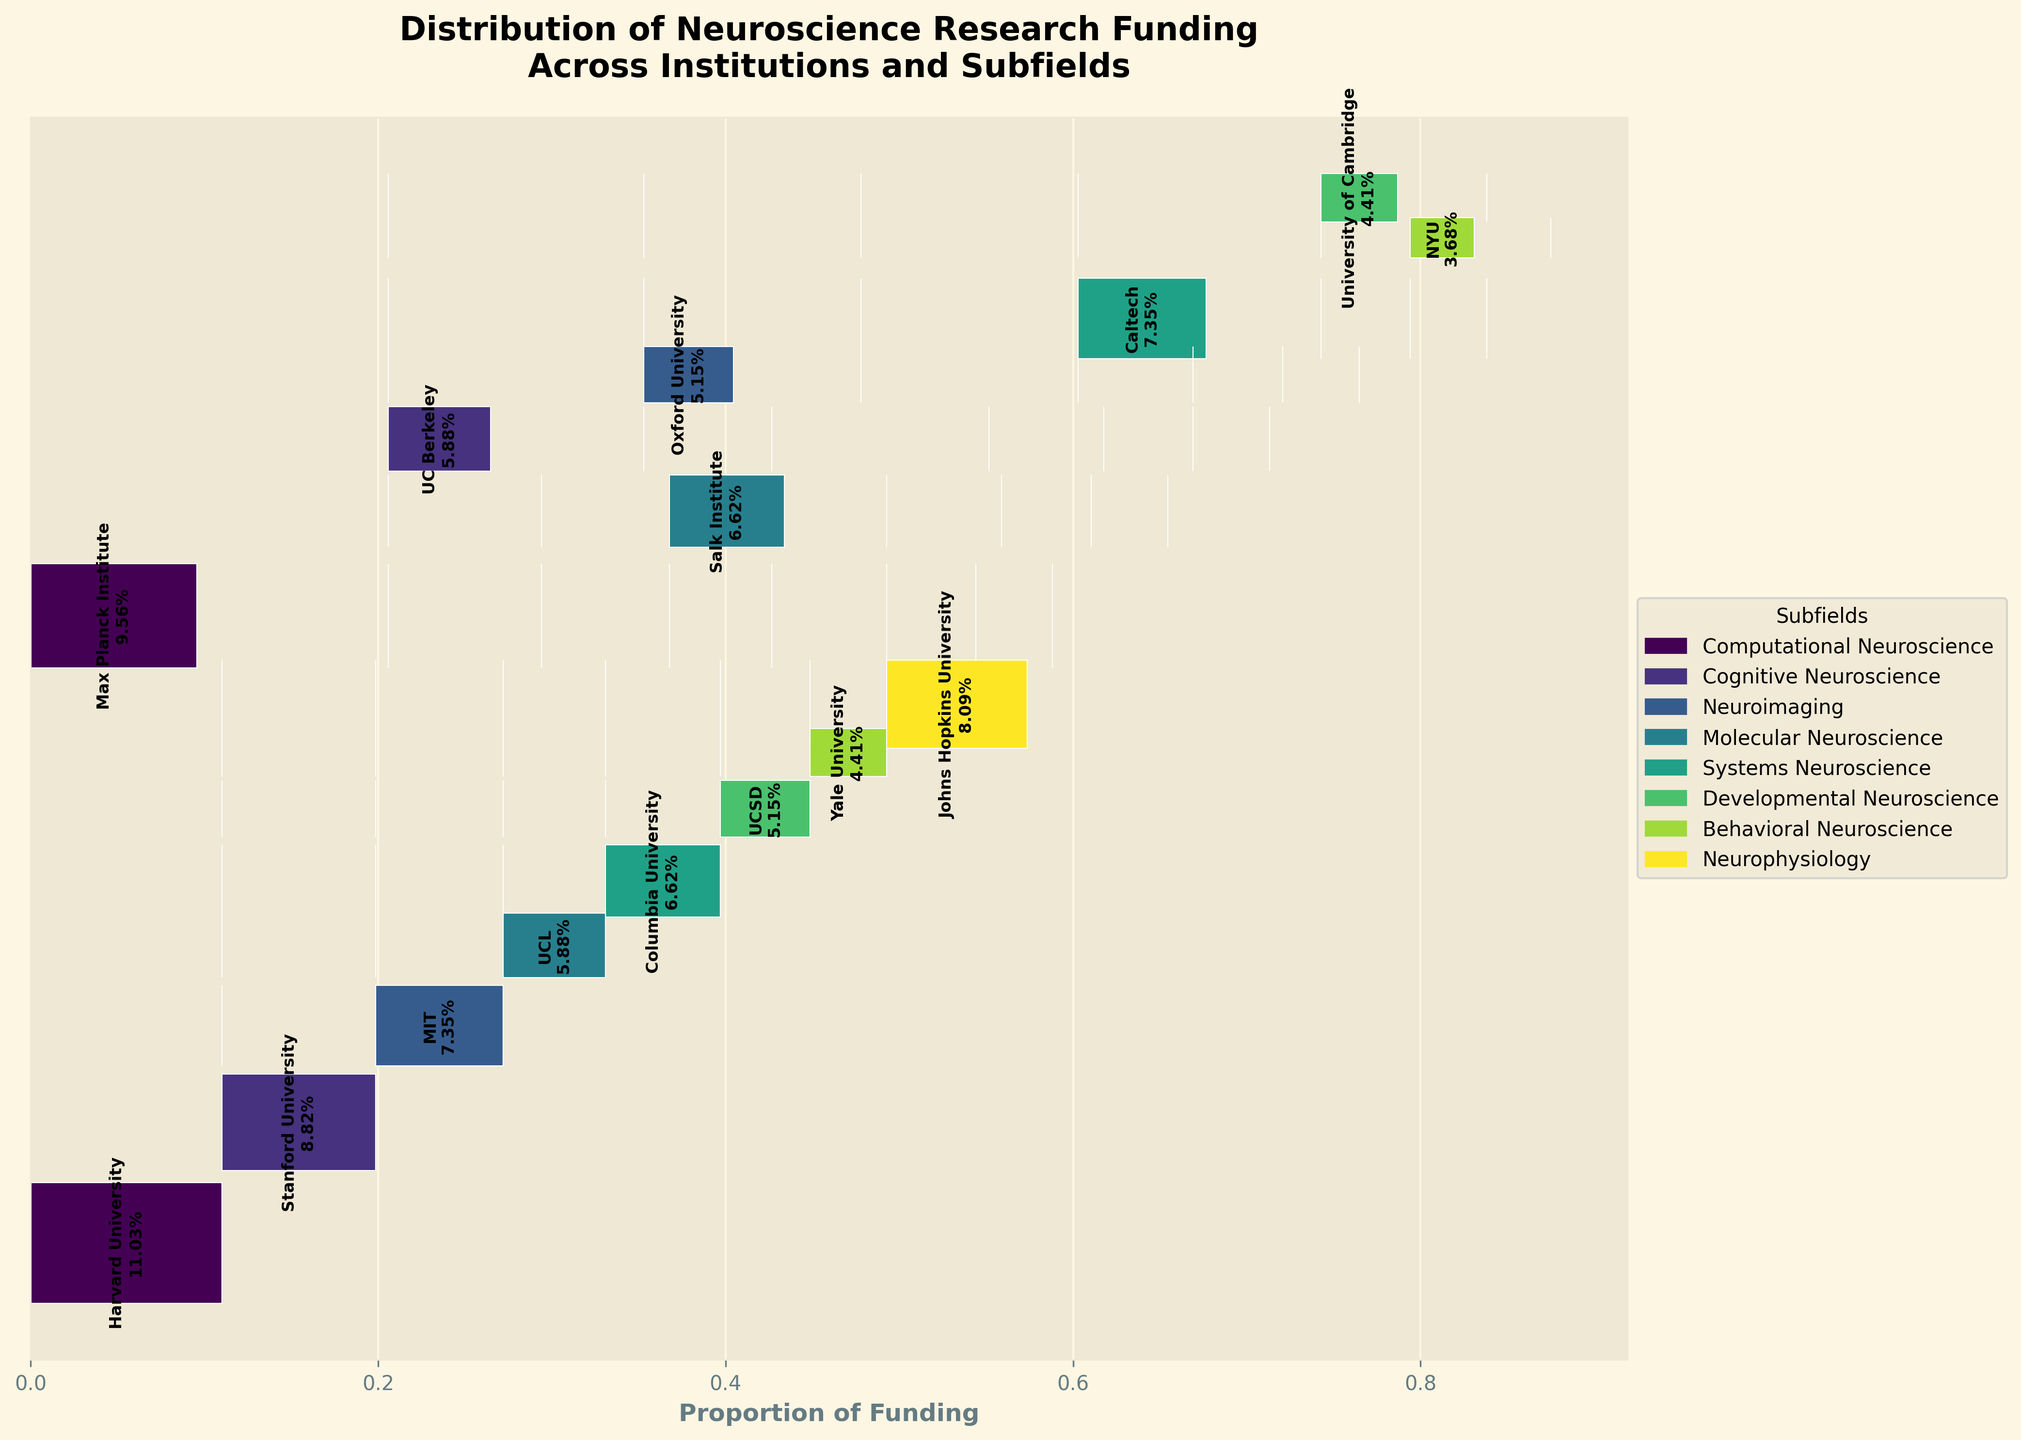What is the title of the plot? The title of the plot is usually displayed at the top. For this figure, it reads "Distribution of Neuroscience Research Funding Across Institutions and Subfields".
Answer: Distribution of Neuroscience Research Funding Across Institutions and Subfields Which subfield received the highest funding from a single institution, and what is the amount? By examining the lengths of the horizontal bars corresponding to each subfield, the longest bar is for Harvard University in Computational Neuroscience. The funding amount is indicated by the text label on the bar.
Answer: Computational Neuroscience, $15,000,000 How is the funding proportion for Yale University's Behavioral Neuroscience displayed in the plot? The funding proportion is displayed as a horizontal bar within the Behavioral Neuroscience segment. By observing the length and the percentage label on it, you can tell the proportion. Based on the data and the plot, Yale University’s bar is in the Behavioral Neuroscience section with a proportion of 6.25%.
Answer: 6.25% What is the total funding amount for Molecular Neuroscience across all institutions? Find the bars corresponding to Molecular Neuroscience, then sum the funding amounts indicated by their lengths and the labels. Salk Institute ($9,000,000) + UCL ($8,000,000) totals $17,000,000.
Answer: $17,000,000 Which institution has the smallest funding proportion in Developmental Neuroscience, and what is the proportion? Look at the horizontal bars within the Developmental Neuroscience segment and compare their lengths. The smallest bar would be for University of Cambridge, with the label indicating the proportion.
Answer: University of Cambridge, 3.13% Which two institutions have the largest combined funding in Neuroimaging? Identify the two longest bars in the Neuroimaging segment. MIT ($10,000,000) and Oxford University ($7,000,000) together have the largest combined funding. Adding these amounts gives $17,000,000.
Answer: MIT and Oxford University, $17,000,000 What proportion of the total funding is allocated to Stanford University's Cognitive Neuroscience? Examine the length of the vertical bar in the Cognitive Neuroscience segment corresponding to Stanford University and read the proportion labeled on it, which is 12.50%.
Answer: 12.50% Compare the funding for Systems Neuroscience and Cognitive Neuroscience subfields across all institutions. Which received more funding and by how much? Sum the funding amounts for Systems Neuroscience (Columbia $9,000,000 + Caltech $10,000,000) and Cognitive Neuroscience (Stanford $12,000,000 + UC Berkeley $8,000,000). Systems Neuroscience received $19,000,000, and Cognitive Neuroscience received $20,000,000. The difference is $1,000,000.
Answer: Cognitive Neuroscience, $1,000,000 Which subfield has the most diverse funding distribution across institutions? Observe the horizontal bars for each subfield. The subfield with bars of varied lengths and proportions across the most institutions indicates the most diverse funding distribution. Computational Neuroscience is funded by different institutions (Harvard $15,000,000 and Max Planck $13,000,000).
Answer: Computational Neuroscience What is the total funding across all subfields for Max Planck Institute and how does it compare to Harvard University? Max Planck Institute has funding in Computational Neuroscience ($13,000,000). Harvard University has funding in Computational Neuroscience ($15,000,000). Compare the sums, Max Planck Institute's total is $13,000,000 and Harvard's is $15,000,000. Harvard received $2,000,000 more.
Answer: Max Planck Institute: $13,000,000, Harvard University: $15,000,000, Harvard received $2,000,000 more 